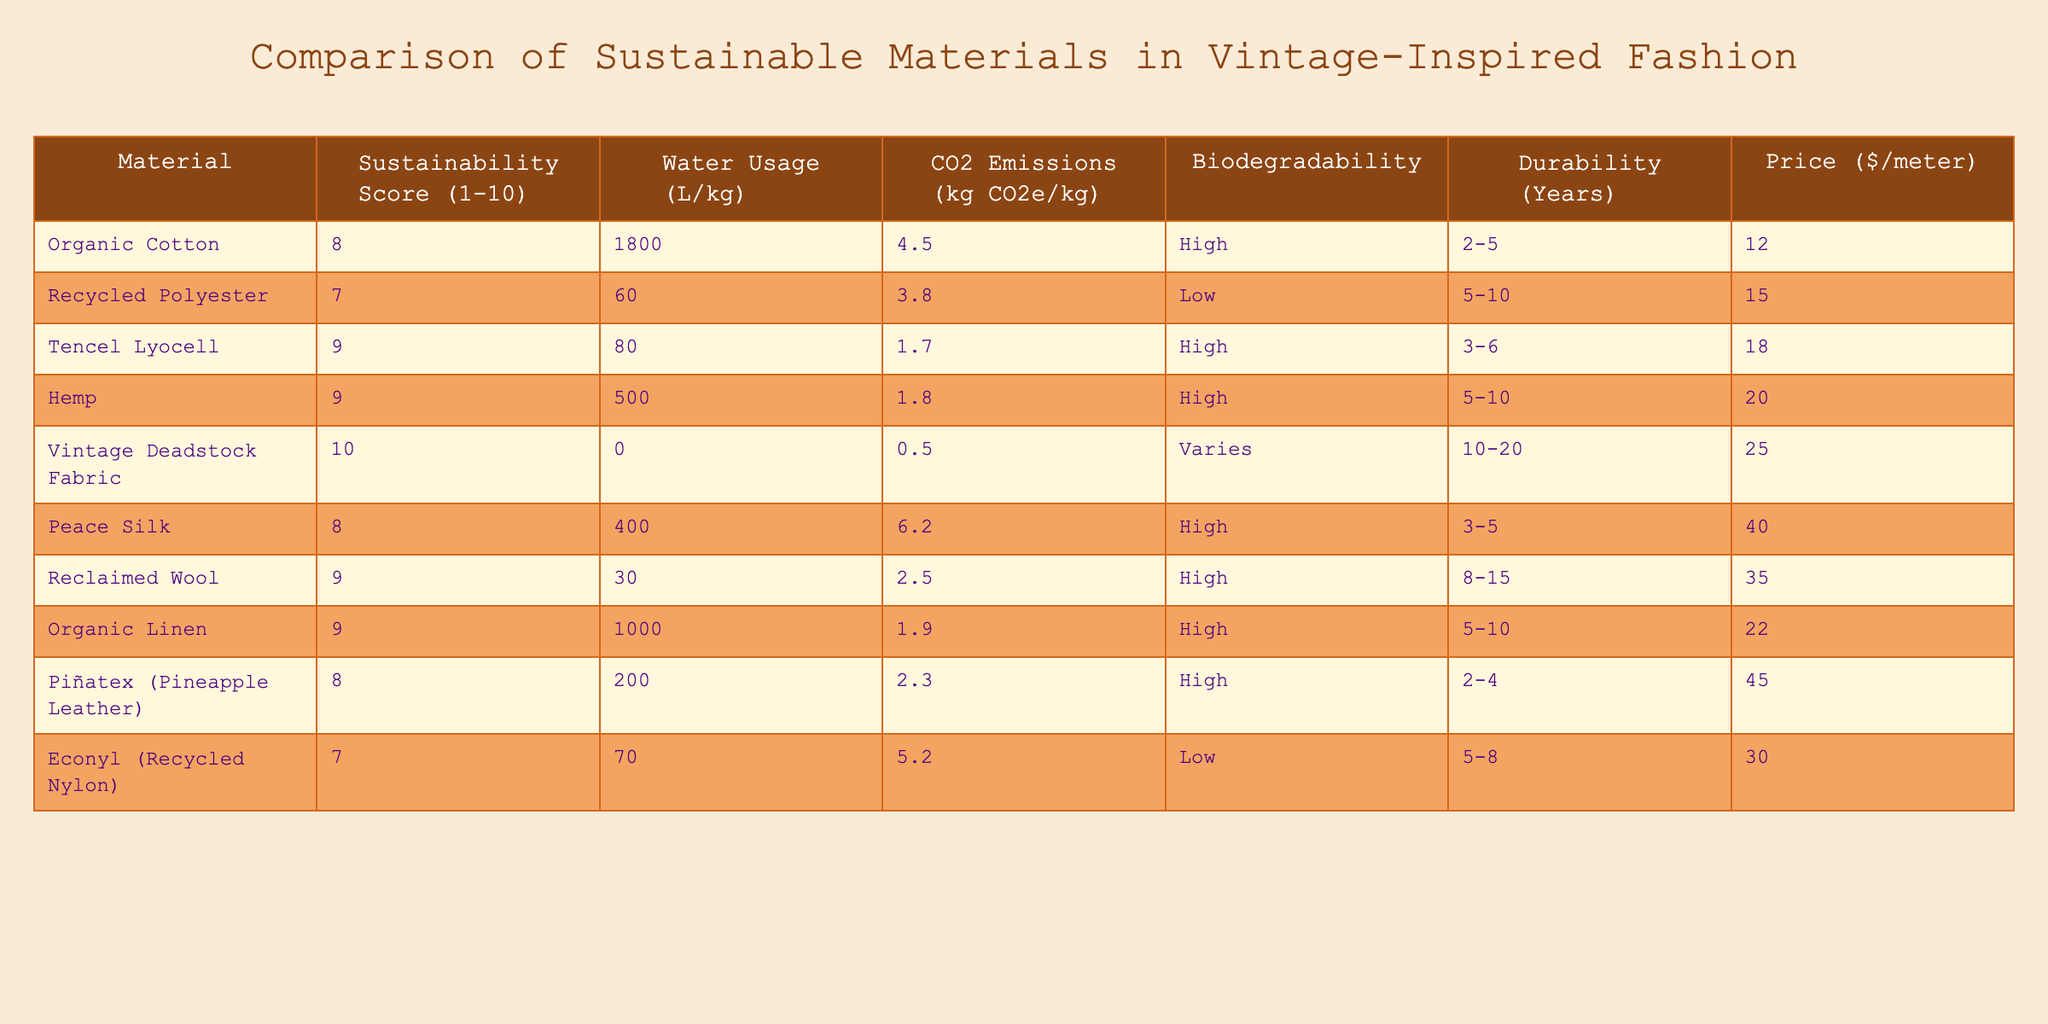What is the sustainability score of Vintage Deadstock Fabric? According to the table, the sustainability score for Vintage Deadstock Fabric is directly listed as 10.
Answer: 10 Which material has the highest water usage? Looking at the water usage column, Organic Cotton has the highest number at 1800 L/kg, which exceeds all other materials listed.
Answer: Organic Cotton What are the CO2 emissions of Tencel Lyocell? The table shows that Tencel Lyocell has CO2 emissions of 1.7 kg CO2e/kg as indicated in the respective column.
Answer: 1.7 Is Recycled Polyester biodegradable? The table states that Recycled Polyester has a low level of biodegradability, confirming it is not biodegradable in a significant manner.
Answer: No Which material is the most durable and how many years can it last? The table indicates that Vintage Deadstock Fabric can last between 10 to 20 years, making it the most durable option available.
Answer: 10-20 years What is the average sustainability score of all materials listed? To calculate the average, we add all sustainability scores: (8 + 7 + 9 + 9 + 10 + 8 + 9 + 9 + 8 + 7) = 82. There are 10 materials, so the average is 82 / 10 = 8.2.
Answer: 8.2 What material has the lowest CO2 emissions? By reviewing the CO2 emissions column, Vintage Deadstock Fabric shows the lowest emissions at 0.5 kg CO2e/kg.
Answer: Vintage Deadstock Fabric How much does Piñatex cost per meter compared to Organic Linen? Piñatex costs $45 per meter, while Organic Linen costs $22 per meter. The difference is $45 - $22 = $23, meaning Piñatex is $23 more expensive.
Answer: $23 more Which materials have high biodegradability? The table specifies "High" biodegradability for Organic Cotton, Tencel Lyocell, Hemp, Peace Silk, Reclaimed Wool, and Organic Linen.
Answer: 6 materials If we combine the durability of Hemp and Peace Silk, what would their total durability be? The durability for Hemp is 5-10 years, and for Peace Silk, it is 3-5 years. The highest total combined durability would be 10 + 5 = 15 years, while the lowest would be 5 + 3 = 8 years.
Answer: 8-15 years 